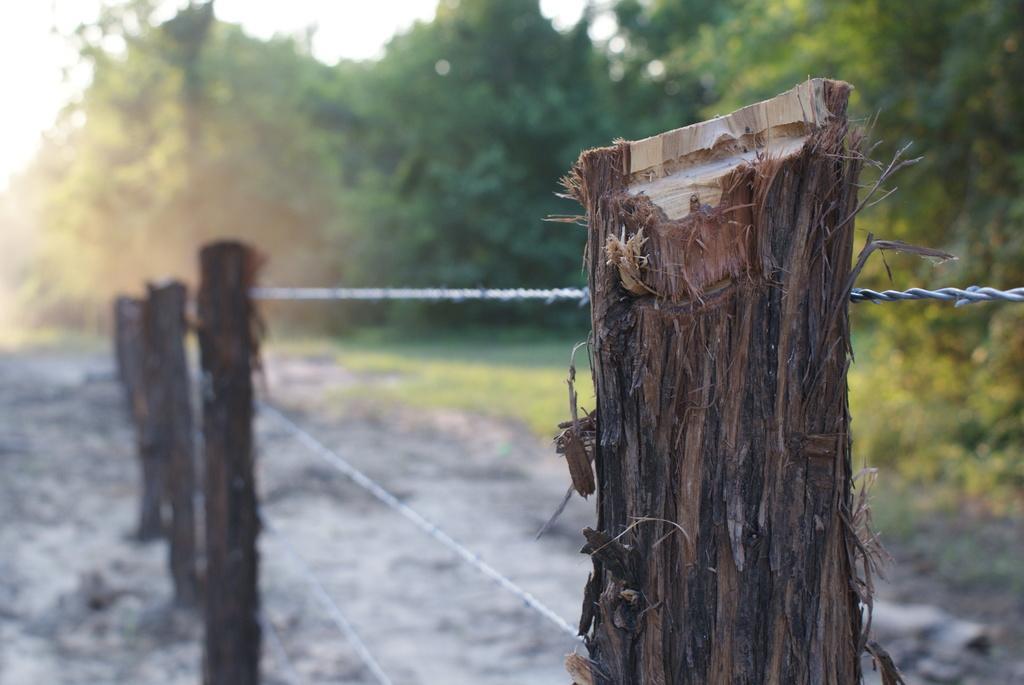Can you describe this image briefly? In this image I can see wooden sticks visible on the ground and I can see fence at the top I can see the sky and trees. 